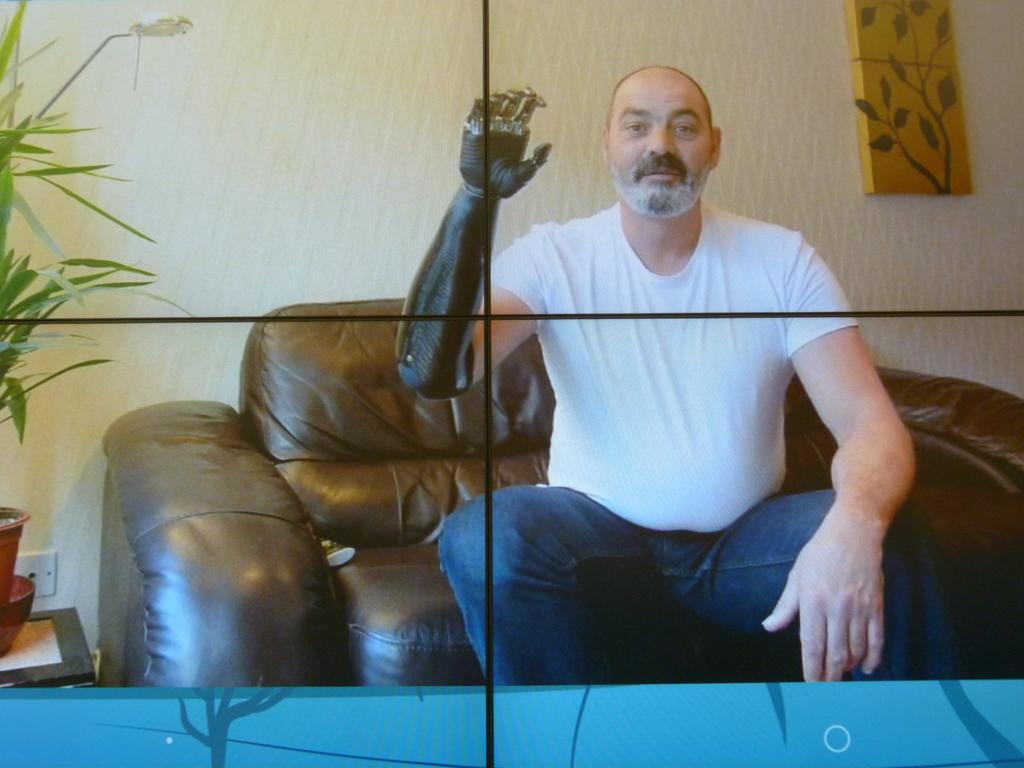What is the person in the image doing? The person is sitting on a chair in the image. What can be seen behind the person? There is a wall behind the person in the image. Are there any objects on a table in the image? Yes, there is a house plant on a table in the image. What type of jar can be seen on the table next to the person? There is no jar present on the table next to the person in the image. 